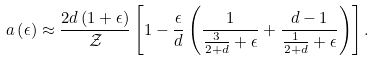Convert formula to latex. <formula><loc_0><loc_0><loc_500><loc_500>a \left ( \epsilon \right ) \approx \frac { 2 d \left ( 1 + \epsilon \right ) } { \mathcal { Z } } \left [ 1 - \frac { \epsilon } { d } \left ( \frac { 1 } { \frac { 3 } { 2 + d } + \epsilon } + \frac { d - 1 } { \frac { 1 } { 2 + d } + \epsilon } \right ) \right ] .</formula> 